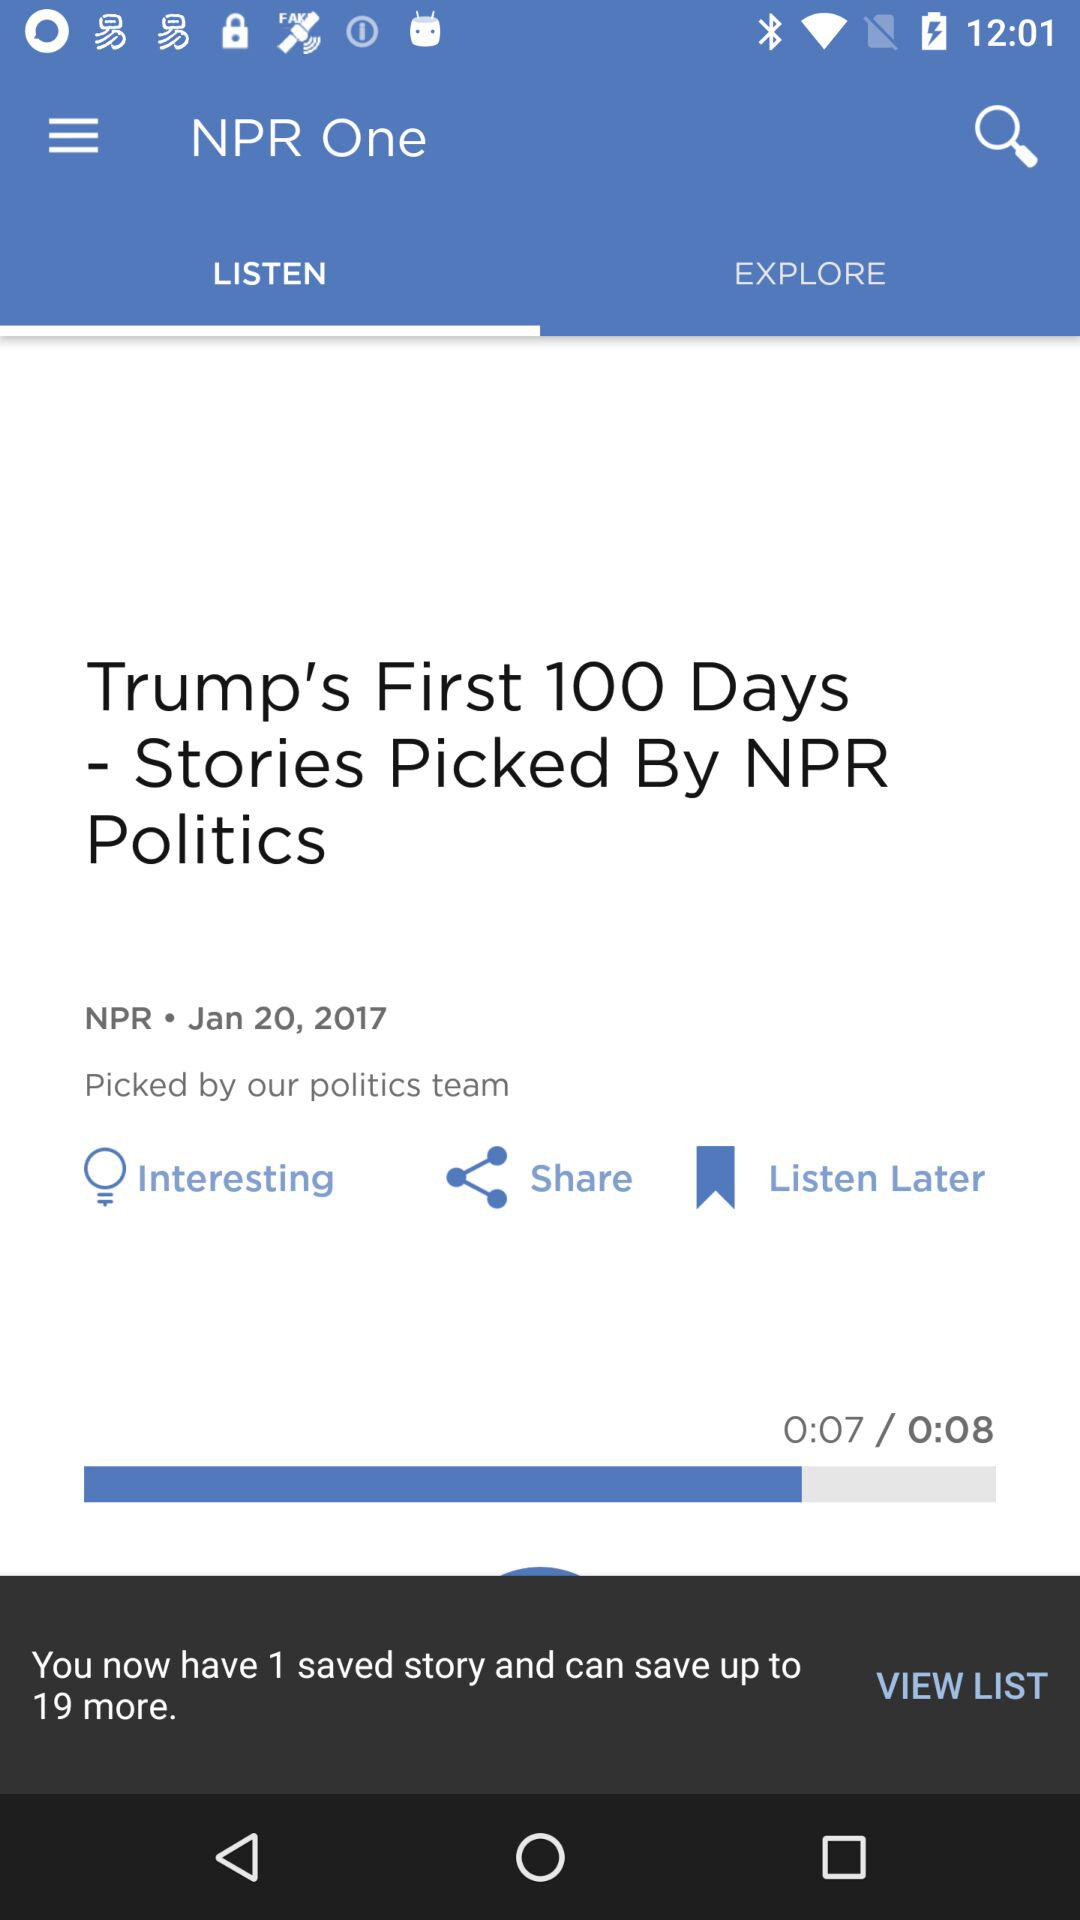How many more stories can the user save?
Answer the question using a single word or phrase. 19 